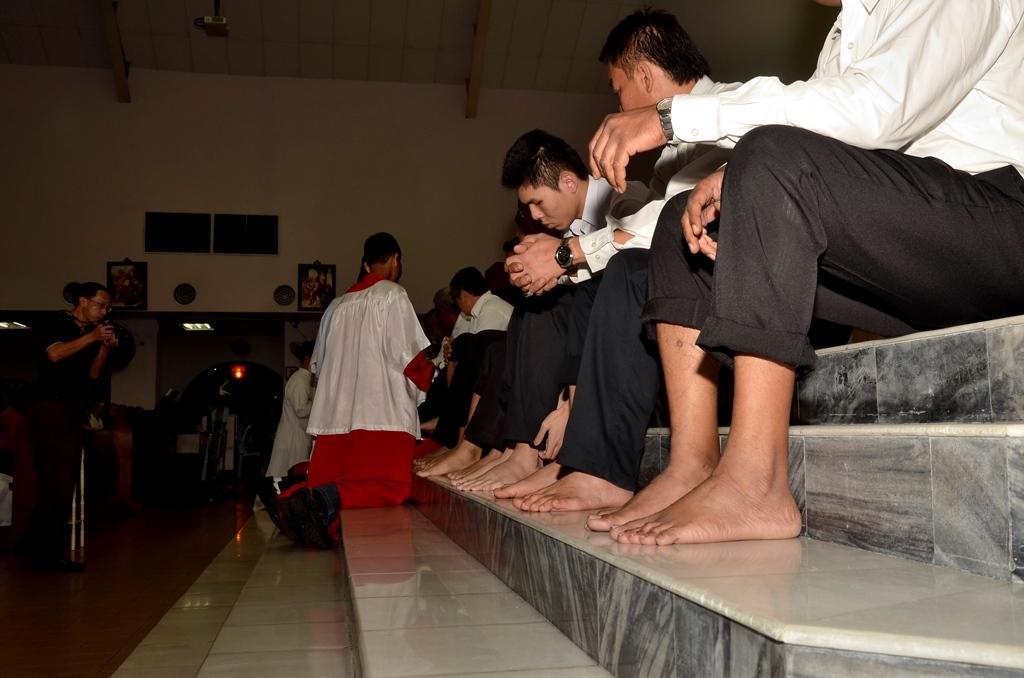Describe this image in one or two sentences. There are some persons sitting on the stairs as we can see on the right side of this image. There is one person standing and holding a camera on the left side of this image. There is a wall in the background. There are some photo frames attached on it. There is one projector is attached to the roof at the top of this image. 